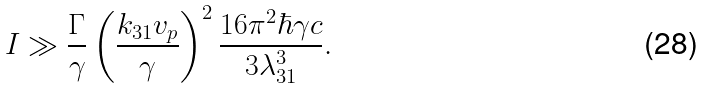Convert formula to latex. <formula><loc_0><loc_0><loc_500><loc_500>I \gg \frac { \Gamma } { \gamma } \left ( \frac { k _ { 3 1 } v _ { p } } \gamma \right ) ^ { 2 } \frac { 1 6 \pi ^ { 2 } \hbar { \gamma } c } { 3 \lambda _ { 3 1 } ^ { 3 } } .</formula> 